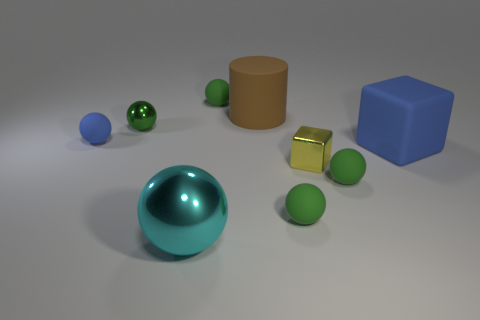What material is the thing that is the same color as the big rubber block?
Keep it short and to the point. Rubber. What number of small things have the same color as the cylinder?
Provide a succinct answer. 0. What number of objects are either large blue rubber objects right of the tiny blue matte thing or green things behind the matte cube?
Make the answer very short. 3. What number of large blue blocks are to the left of the green sphere that is behind the big brown rubber cylinder?
Your answer should be compact. 0. What color is the big thing that is the same material as the cylinder?
Provide a succinct answer. Blue. Is there a cyan metal cylinder of the same size as the green metallic thing?
Offer a very short reply. No. The other shiny object that is the same size as the green metal object is what shape?
Make the answer very short. Cube. Are there any large purple metallic objects that have the same shape as the small yellow shiny object?
Your response must be concise. No. Does the tiny block have the same material as the tiny green thing that is to the left of the large cyan metal object?
Give a very brief answer. Yes. Are there any other big cubes that have the same color as the shiny block?
Provide a succinct answer. No. 